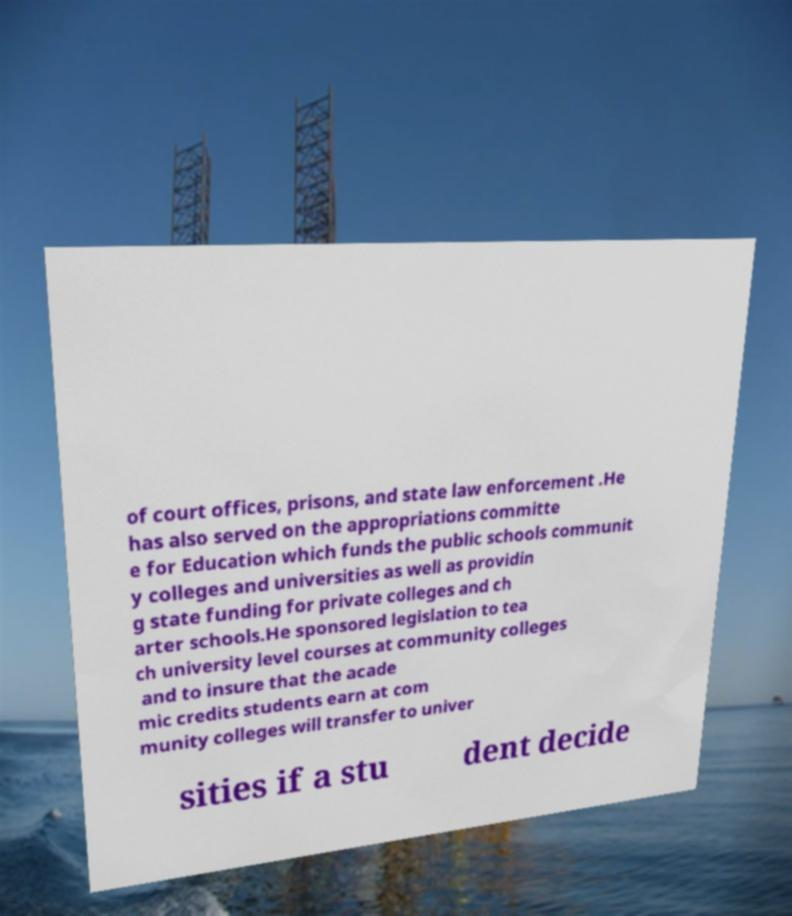There's text embedded in this image that I need extracted. Can you transcribe it verbatim? of court offices, prisons, and state law enforcement .He has also served on the appropriations committe e for Education which funds the public schools communit y colleges and universities as well as providin g state funding for private colleges and ch arter schools.He sponsored legislation to tea ch university level courses at community colleges and to insure that the acade mic credits students earn at com munity colleges will transfer to univer sities if a stu dent decide 